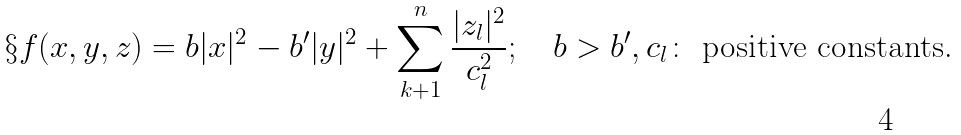<formula> <loc_0><loc_0><loc_500><loc_500>\S f ( x , y , z ) = b | x | ^ { 2 } - b ^ { \prime } | y | ^ { 2 } + \sum _ { k + 1 } ^ { n } \frac { | z _ { l } | ^ { 2 } } { c _ { l } ^ { 2 } } ; \quad b > b ^ { \prime } , c _ { l } \colon \text { positive constants.}</formula> 